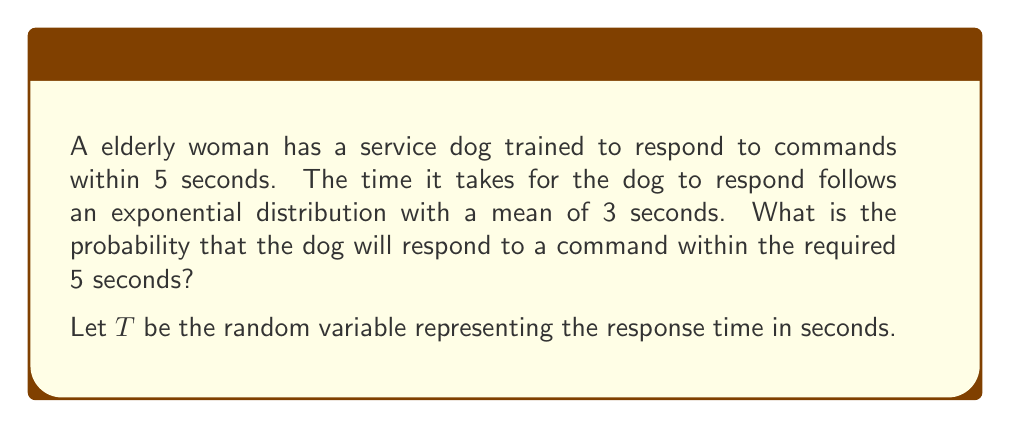What is the answer to this math problem? To solve this problem, we'll follow these steps:

1) The exponential distribution is given by the probability density function:
   $$f(t) = \lambda e^{-\lambda t}, \text{ for } t \geq 0$$
   where $\lambda$ is the rate parameter.

2) We're given that the mean of the distribution is 3 seconds. For an exponential distribution, the mean is equal to $\frac{1}{\lambda}$. So:
   $$\frac{1}{\lambda} = 3$$
   $$\lambda = \frac{1}{3}$$

3) We want to find $P(T \leq 5)$, which is the cumulative distribution function (CDF) of the exponential distribution:
   $$P(T \leq t) = 1 - e^{-\lambda t}$$

4) Substituting our values:
   $$P(T \leq 5) = 1 - e^{-\frac{1}{3} \cdot 5}$$

5) Simplifying:
   $$P(T \leq 5) = 1 - e^{-\frac{5}{3}}$$
   $$= 1 - (e^{-1})^{\frac{5}{3}}$$
   $$= 1 - (\frac{1}{e})^{\frac{5}{3}}$$
   $$\approx 0.8111$$

Therefore, the probability that the dog will respond within 5 seconds is approximately 0.8111 or about 81.11%.
Answer: $1 - e^{-\frac{5}{3}} \approx 0.8111$ 